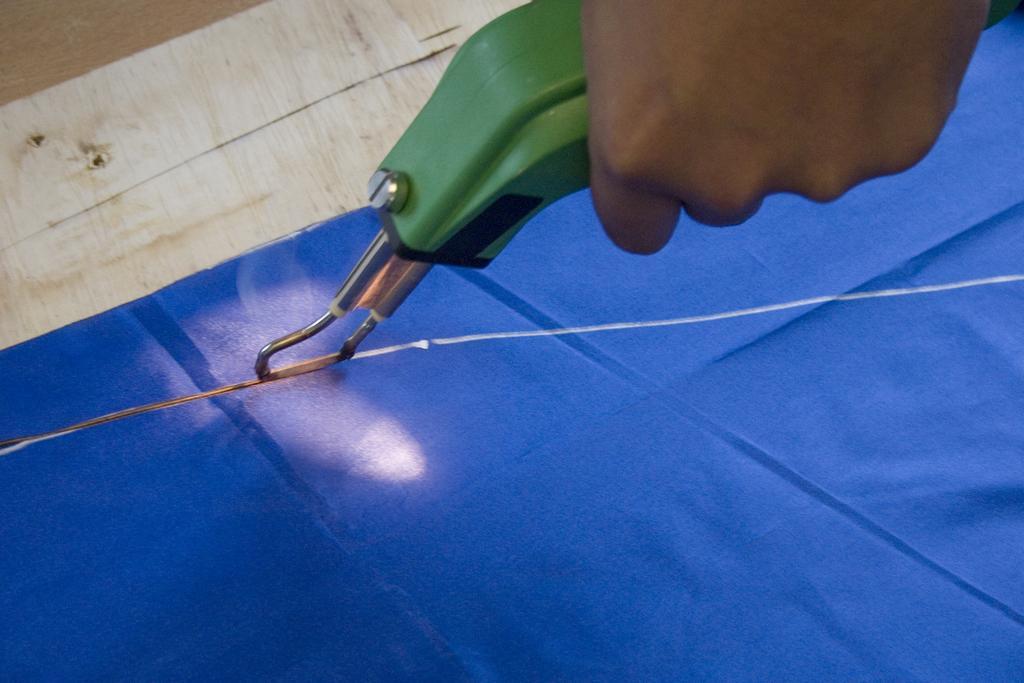Describe this image in one or two sentences. Here in this picture we can see a person cutting a cloth with the help of machine present in his hands. 